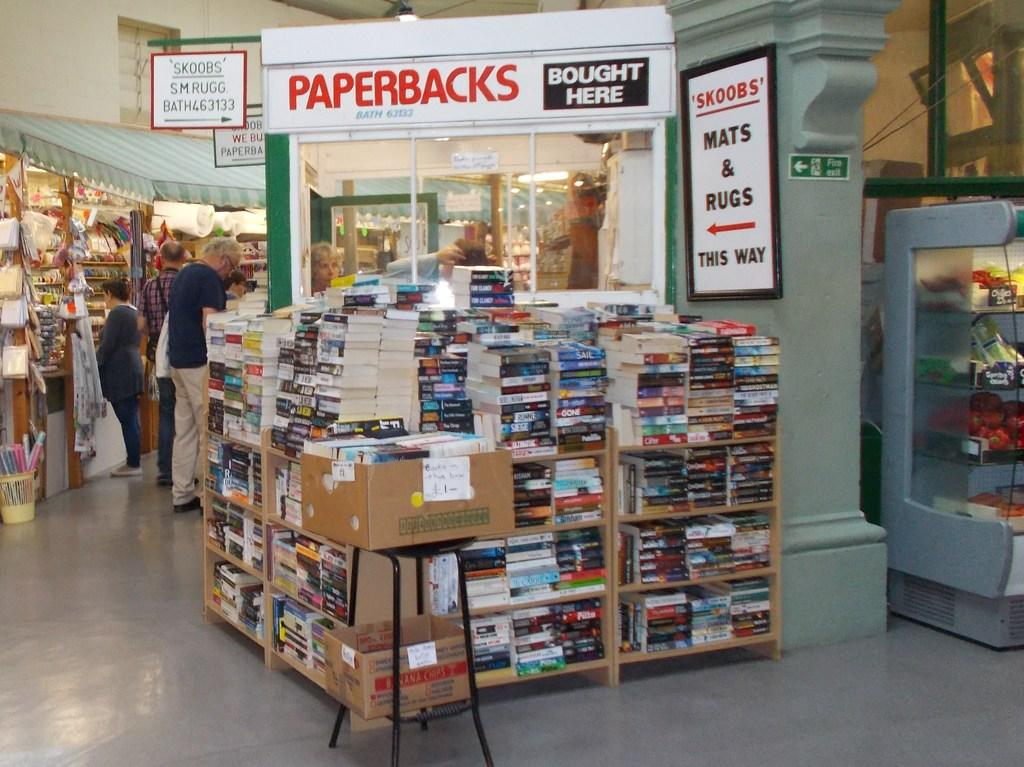<image>
Share a concise interpretation of the image provided. A lot of books are on displayed next to a sign showing the way to mats and rugs on the wall. 